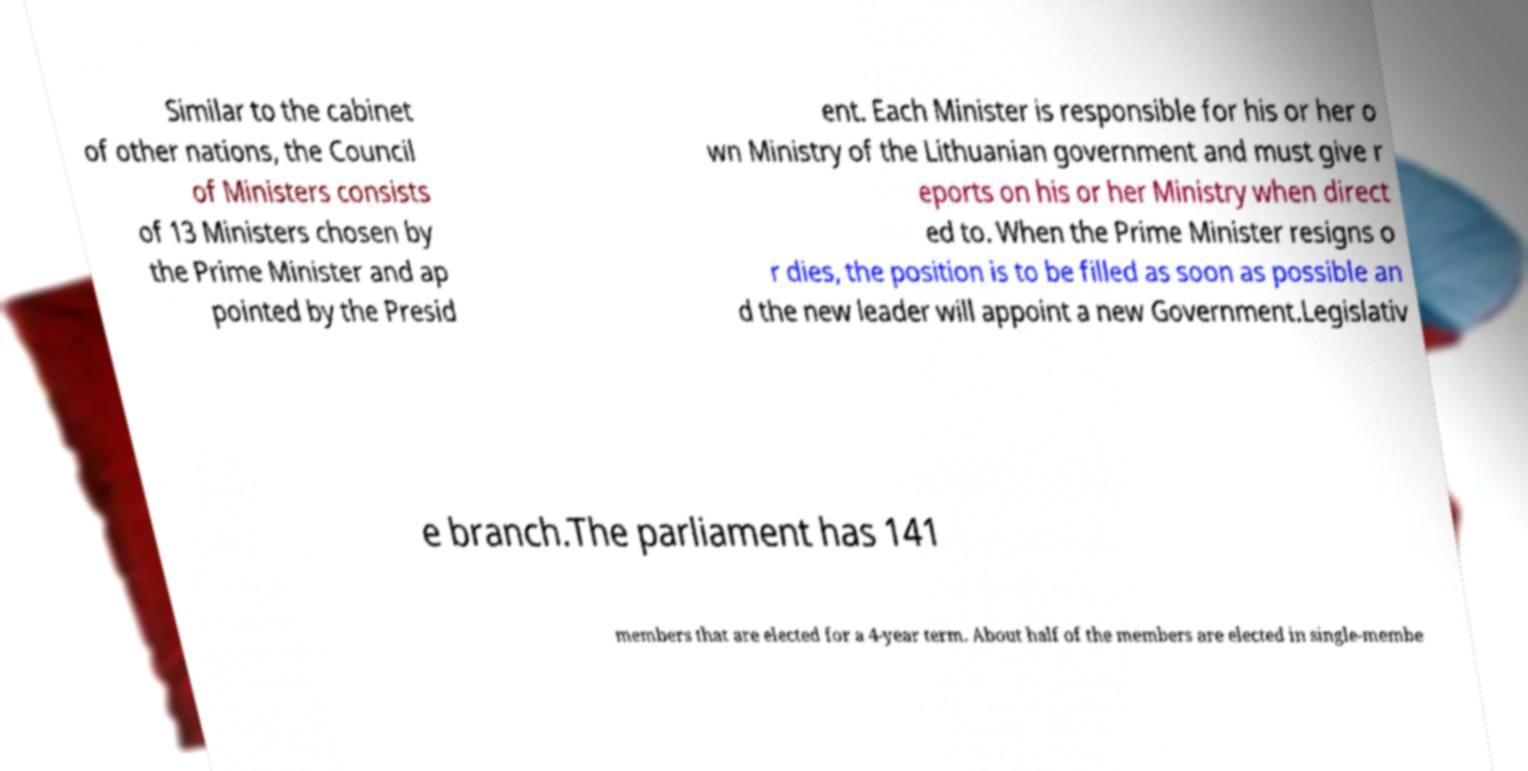Please identify and transcribe the text found in this image. Similar to the cabinet of other nations, the Council of Ministers consists of 13 Ministers chosen by the Prime Minister and ap pointed by the Presid ent. Each Minister is responsible for his or her o wn Ministry of the Lithuanian government and must give r eports on his or her Ministry when direct ed to. When the Prime Minister resigns o r dies, the position is to be filled as soon as possible an d the new leader will appoint a new Government.Legislativ e branch.The parliament has 141 members that are elected for a 4-year term. About half of the members are elected in single-membe 